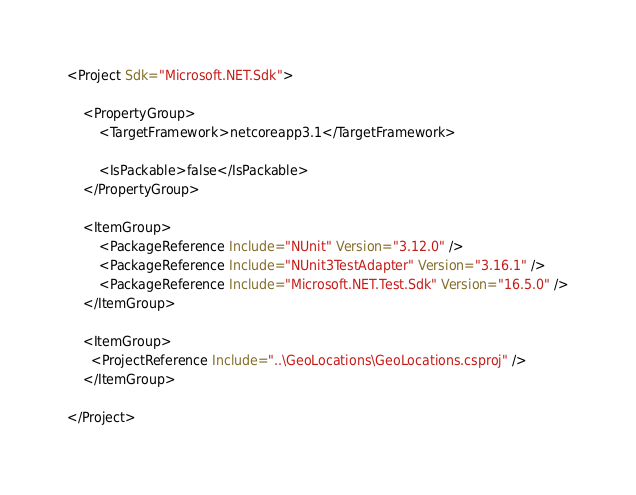Convert code to text. <code><loc_0><loc_0><loc_500><loc_500><_XML_><Project Sdk="Microsoft.NET.Sdk">

    <PropertyGroup>
        <TargetFramework>netcoreapp3.1</TargetFramework>

        <IsPackable>false</IsPackable>
    </PropertyGroup>

    <ItemGroup>
        <PackageReference Include="NUnit" Version="3.12.0" />
        <PackageReference Include="NUnit3TestAdapter" Version="3.16.1" />
        <PackageReference Include="Microsoft.NET.Test.Sdk" Version="16.5.0" />
    </ItemGroup>

    <ItemGroup>
      <ProjectReference Include="..\GeoLocations\GeoLocations.csproj" />
    </ItemGroup>

</Project>
</code> 